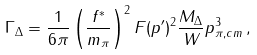<formula> <loc_0><loc_0><loc_500><loc_500>\Gamma _ { \Delta } = \frac { 1 } { 6 \pi } \left ( \frac { f ^ { * } } { m _ { \pi } } \right ) ^ { 2 } F ( p ^ { \prime } ) ^ { 2 } \frac { M _ { \Delta } } { W } p _ { \pi , c m } ^ { 3 } \, ,</formula> 